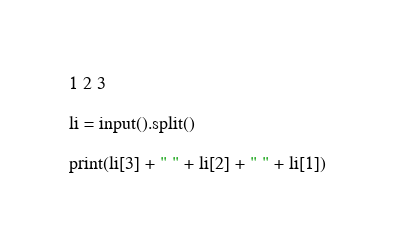<code> <loc_0><loc_0><loc_500><loc_500><_Python_>1 2 3

li = input().split()

print(li[3] + " " + li[2] + " " + li[1])</code> 